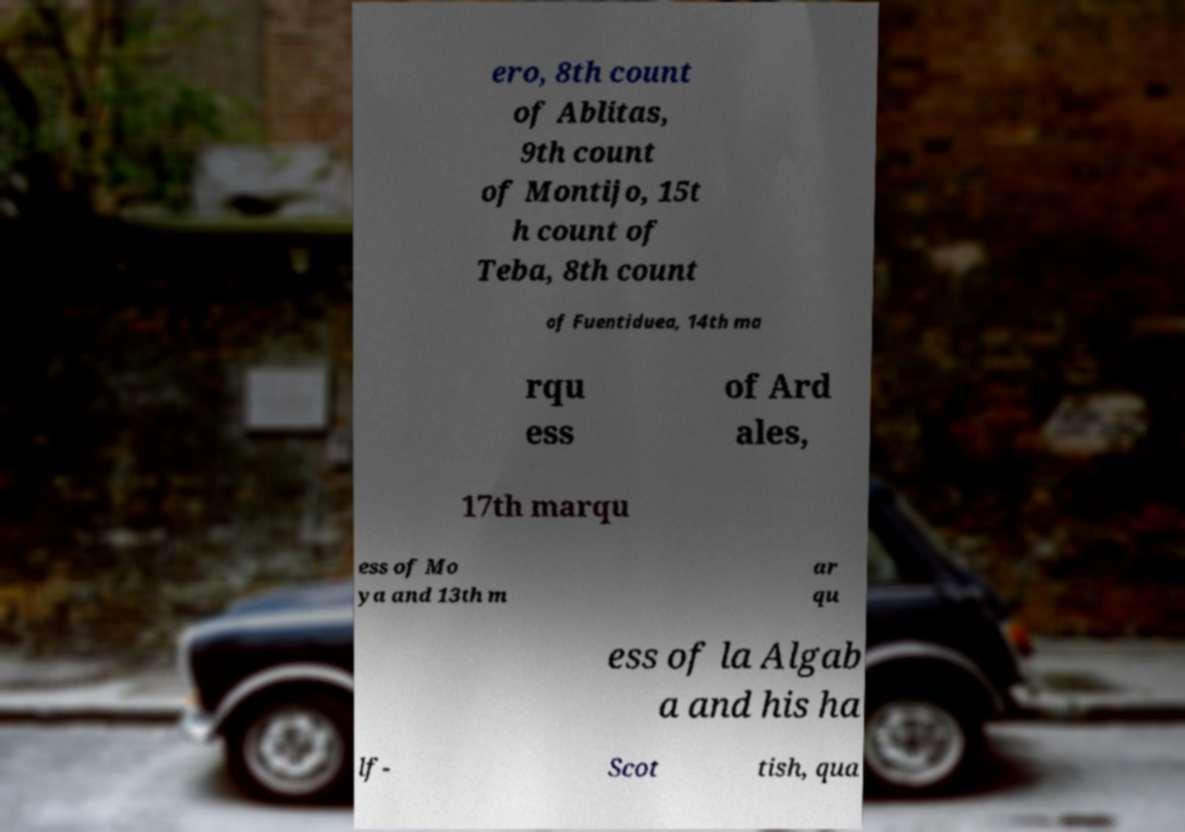Can you read and provide the text displayed in the image?This photo seems to have some interesting text. Can you extract and type it out for me? ero, 8th count of Ablitas, 9th count of Montijo, 15t h count of Teba, 8th count of Fuentiduea, 14th ma rqu ess of Ard ales, 17th marqu ess of Mo ya and 13th m ar qu ess of la Algab a and his ha lf- Scot tish, qua 